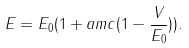Convert formula to latex. <formula><loc_0><loc_0><loc_500><loc_500>E = E _ { 0 } ( 1 + a m c ( 1 - \frac { V } { E _ { 0 } } ) ) .</formula> 